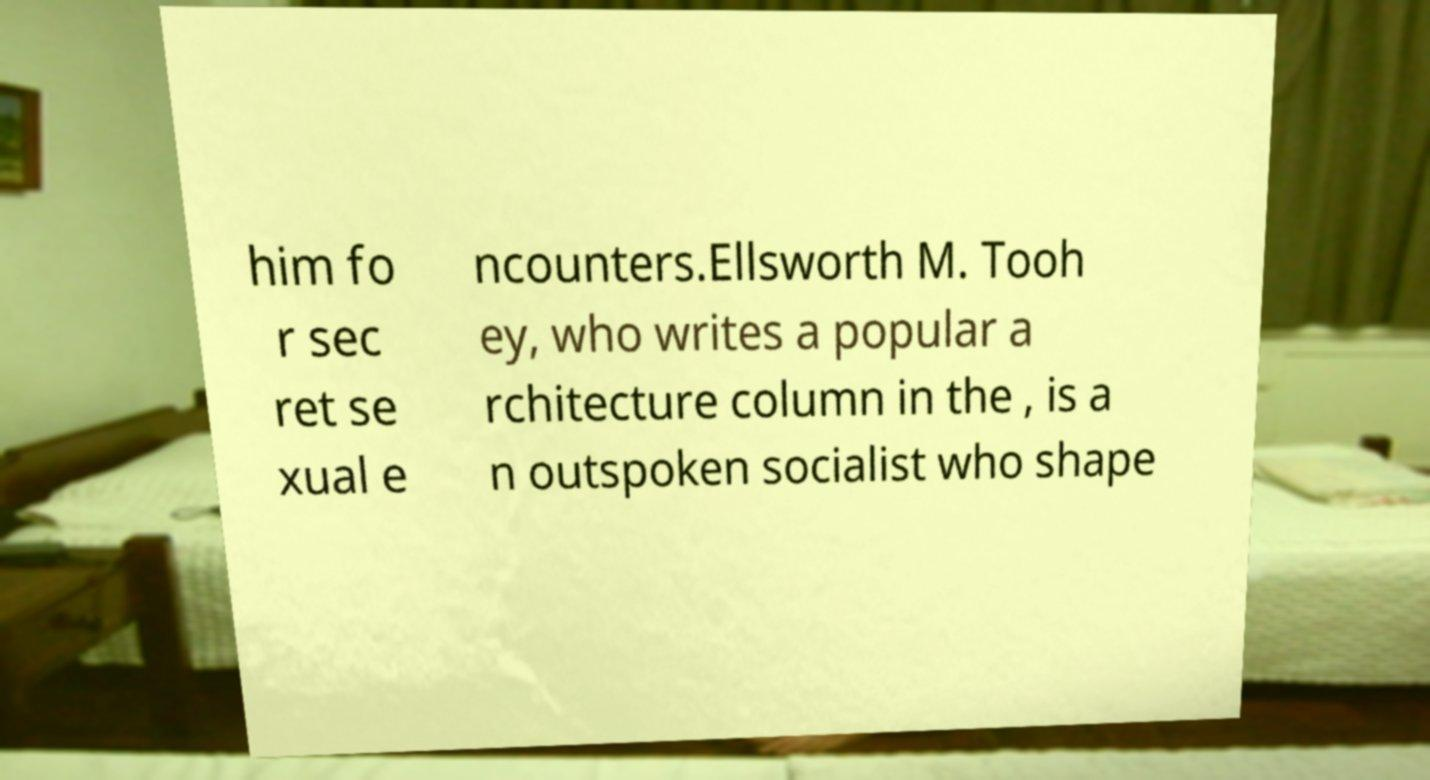Could you assist in decoding the text presented in this image and type it out clearly? him fo r sec ret se xual e ncounters.Ellsworth M. Tooh ey, who writes a popular a rchitecture column in the , is a n outspoken socialist who shape 